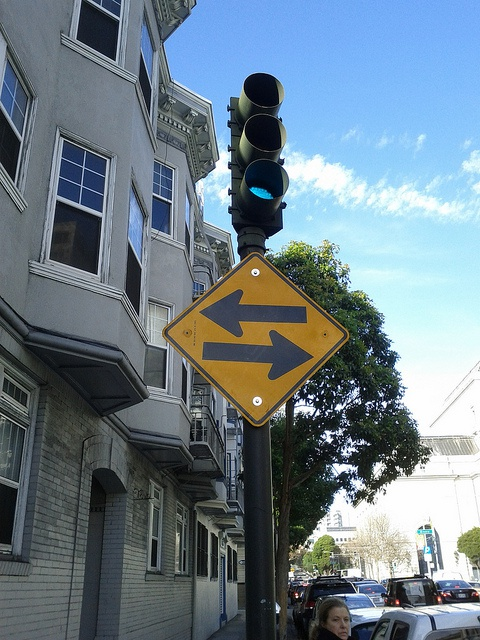Describe the objects in this image and their specific colors. I can see traffic light in gray, black, navy, and darkgray tones, car in gray, black, darkgray, and white tones, car in gray, black, and darkgray tones, people in gray and black tones, and car in gray, black, and darkgray tones in this image. 